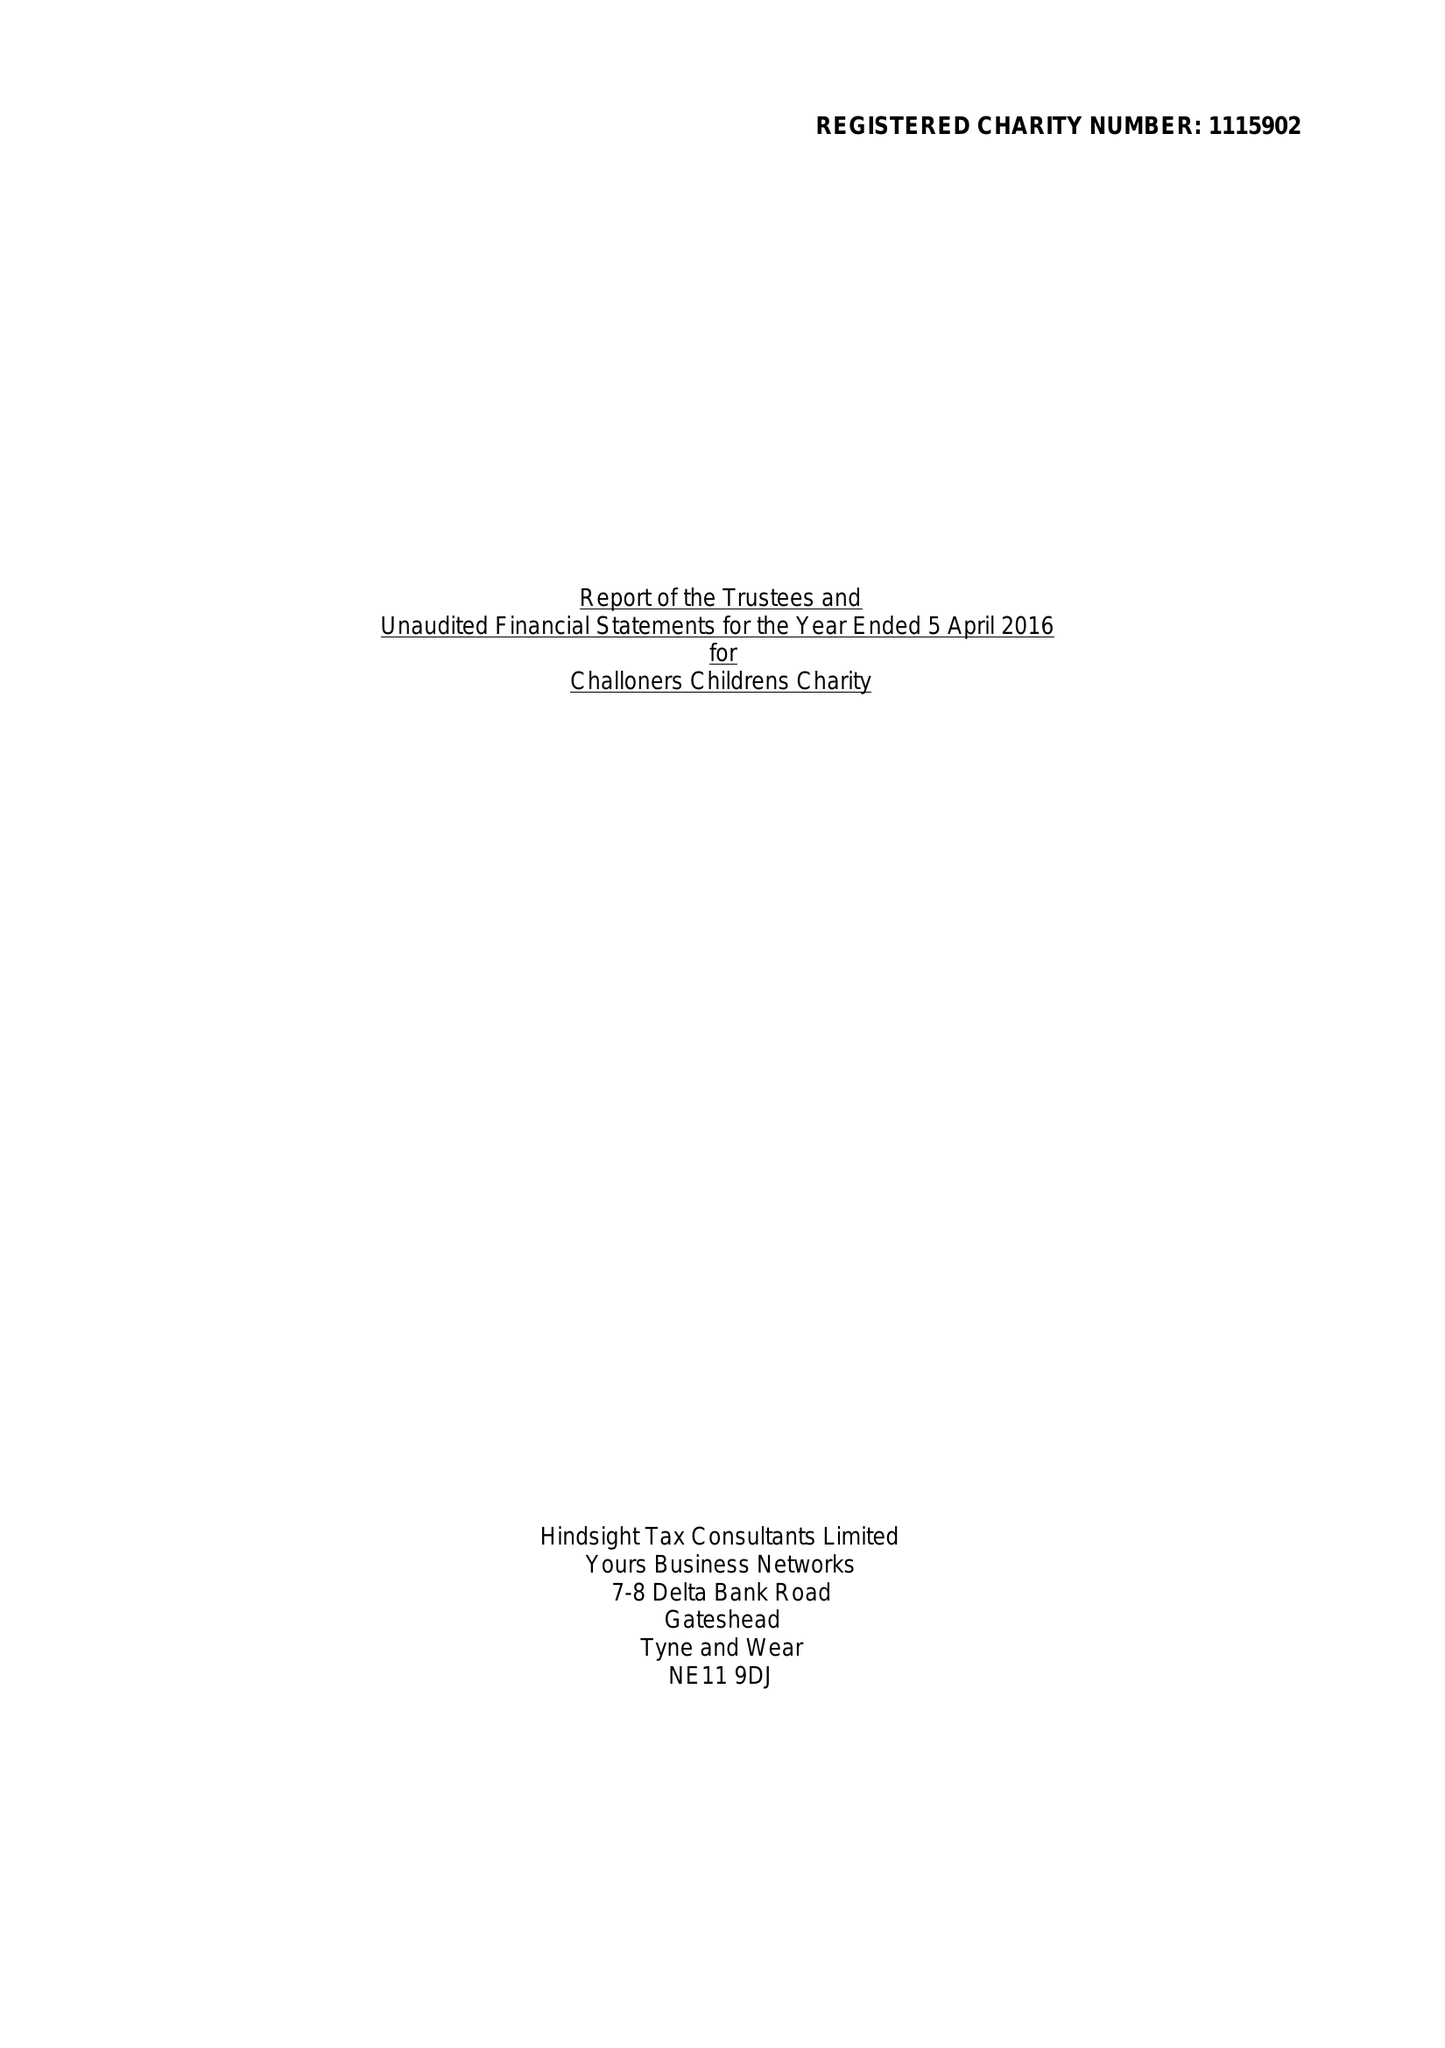What is the value for the address__street_line?
Answer the question using a single word or phrase. 52 ONSLOW SQUARE 